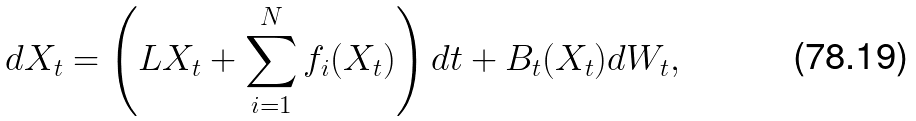<formula> <loc_0><loc_0><loc_500><loc_500>d X _ { t } = \left ( L X _ { t } + \sum _ { i = 1 } ^ { N } f _ { i } ( X _ { t } ) \right ) d t + B _ { t } ( X _ { t } ) d W _ { t } ,</formula> 